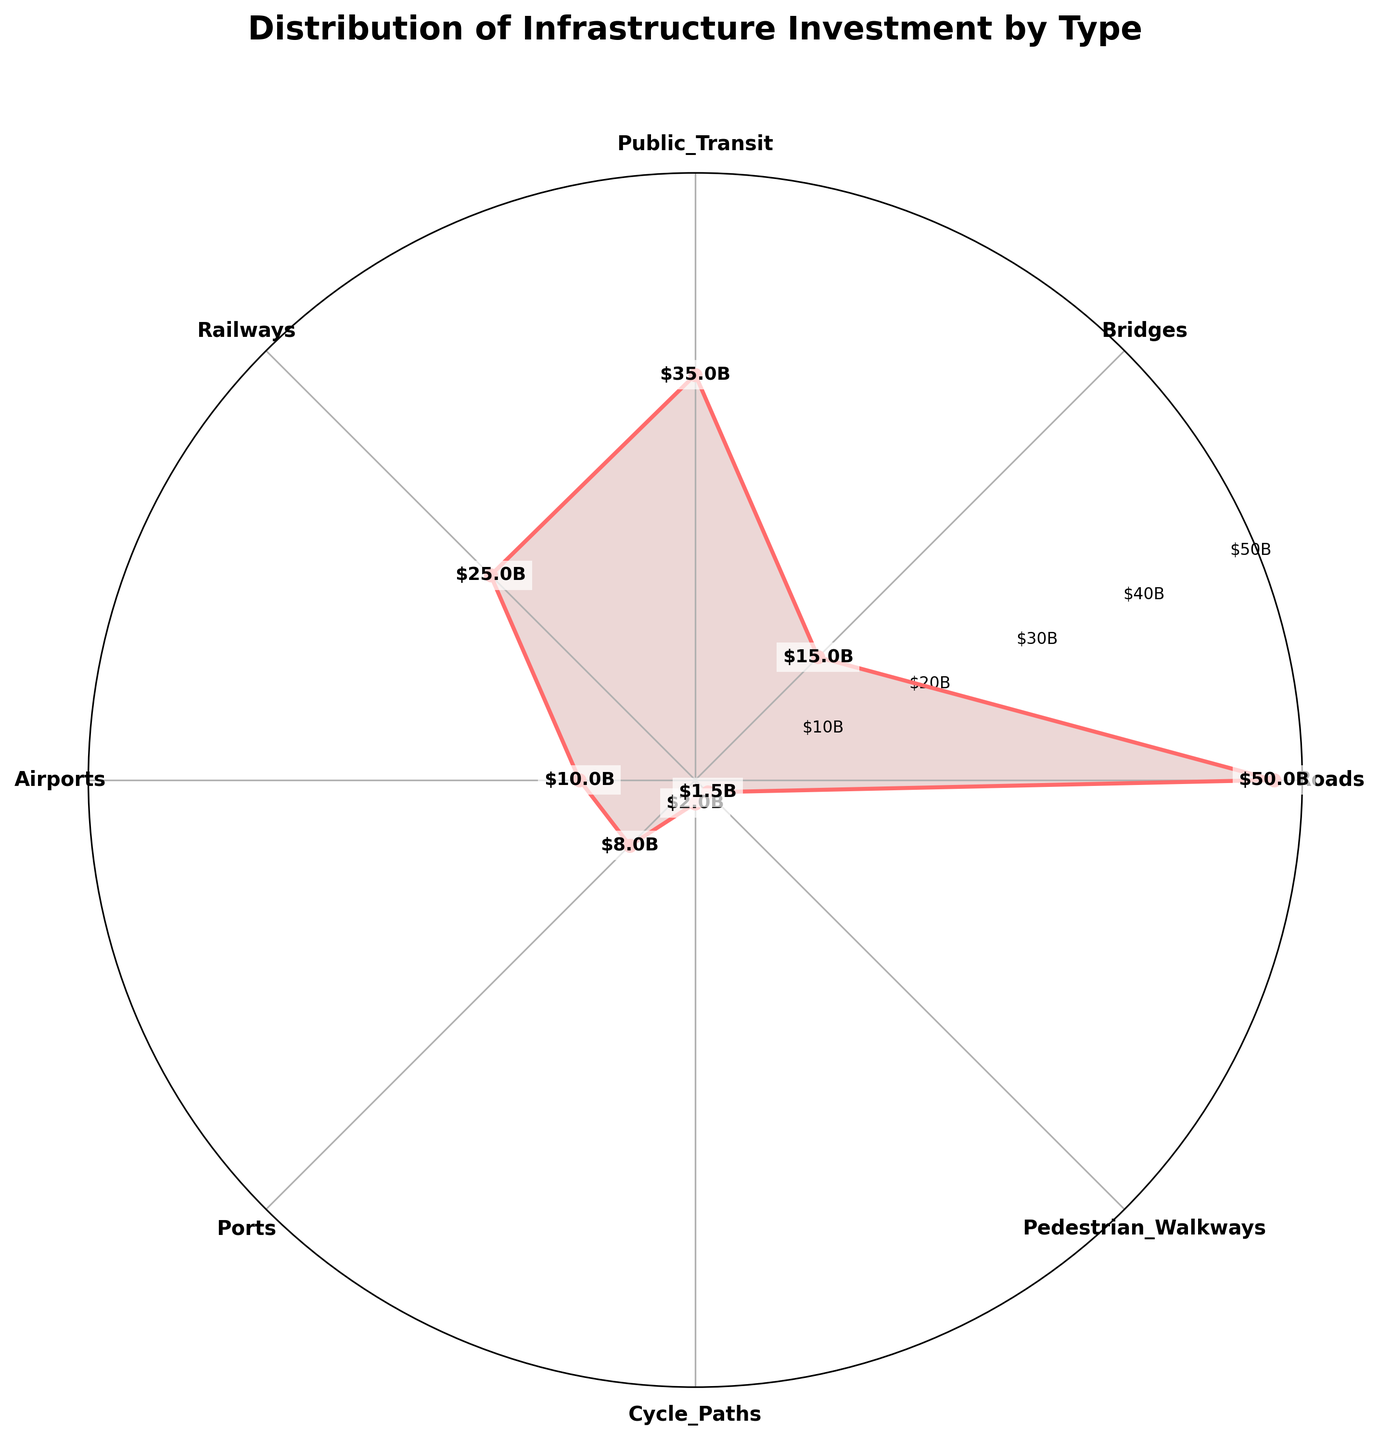How many types of infrastructure investments are displayed in the chart? Count the number of different labeled categories along the circumference of the polar plot.
Answer: 8 Which type of infrastructure investment has the highest amount? Identify the label of the category with the longest radial line or highest plotted value on the chart.
Answer: Roads What is the difference in investment between Public Transit and Airports? Find the values for Public Transit and Airports, then subtract the smaller value from the larger value. (35 - 10)
Answer: 25 billion USD Which types of infrastructure investments have less than 10 billion USD each? Look for categories with values less than the 10 billion USD radial mark.
Answer: Ports, Cycle Paths, Pedestrian Walkways Do Roads and Railways combined have more investment than all other types combined? Sum values for Roads and Railways (50 + 25 = 75). Then sum the values for the other types (15 + 35 + 10 + 8 + 2 + 1.5 = 71.5). Compare the sums (75 > 71.5).
Answer: Yes Which type of infrastructure has the lowest investment, and what is its amount? Identify the label of the category with the shortest radial line or lowest plotted value on the chart.
Answer: Pedestrian Walkways, 1.5 billion USD List the infrastructure types in decreasing order of investment amount. Order the categories based on the lengths of their radial lines or plotted values.
Answer: Roads, Public Transit, Railways, Bridges, Airports, Ports, Cycle Paths, Pedestrian Walkways Is the investment in Bridges more than the investment in Ports and Airports combined? Find the values for Bridges, Ports, and Airports. Sum the values for Ports and Airports (8 + 10 = 18). Compare Bridges (15) with the sum (15 < 18).
Answer: No 